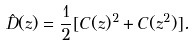Convert formula to latex. <formula><loc_0><loc_0><loc_500><loc_500>\hat { D } ( z ) = \frac { 1 } { 2 } [ C ( z ) ^ { 2 } + C ( z ^ { 2 } ) ] .</formula> 